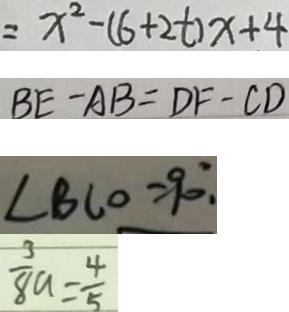Convert formula to latex. <formula><loc_0><loc_0><loc_500><loc_500>= x ^ { 2 } - ( 6 + 2 t ) x + 4 
 B E - A B = D F - C D 
 \angle B C O = 9 0 ^ { \circ } . 
 \frac { 3 } { 8 } a = \frac { 4 } { 5 }</formula> 